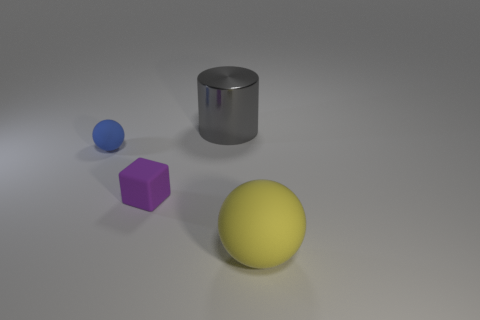What color is the sphere that is right of the tiny matte ball?
Make the answer very short. Yellow. Are there any big rubber balls that have the same color as the metallic thing?
Offer a very short reply. No. The thing that is the same size as the gray cylinder is what color?
Ensure brevity in your answer.  Yellow. Do the metal object and the blue matte object have the same shape?
Ensure brevity in your answer.  No. There is a ball that is behind the yellow rubber thing; what is it made of?
Make the answer very short. Rubber. The tiny matte ball is what color?
Ensure brevity in your answer.  Blue. Does the ball that is to the left of the gray thing have the same size as the matte ball that is in front of the blue object?
Your answer should be very brief. No. What size is the object that is both right of the tiny matte block and behind the tiny purple rubber cube?
Your answer should be very brief. Large. There is a small matte object that is the same shape as the big rubber thing; what is its color?
Make the answer very short. Blue. Are there more big yellow rubber objects to the left of the large yellow thing than big yellow balls in front of the large gray object?
Your answer should be very brief. No. 